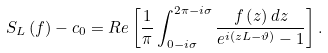Convert formula to latex. <formula><loc_0><loc_0><loc_500><loc_500>S _ { L } \left ( f \right ) - c _ { 0 } = R e \left [ \frac { 1 } { \pi } \int _ { 0 - i \sigma } ^ { 2 \pi - i \sigma } \frac { f \left ( z \right ) d z } { e ^ { i \left ( z L - \vartheta \right ) } - 1 } \right ] .</formula> 